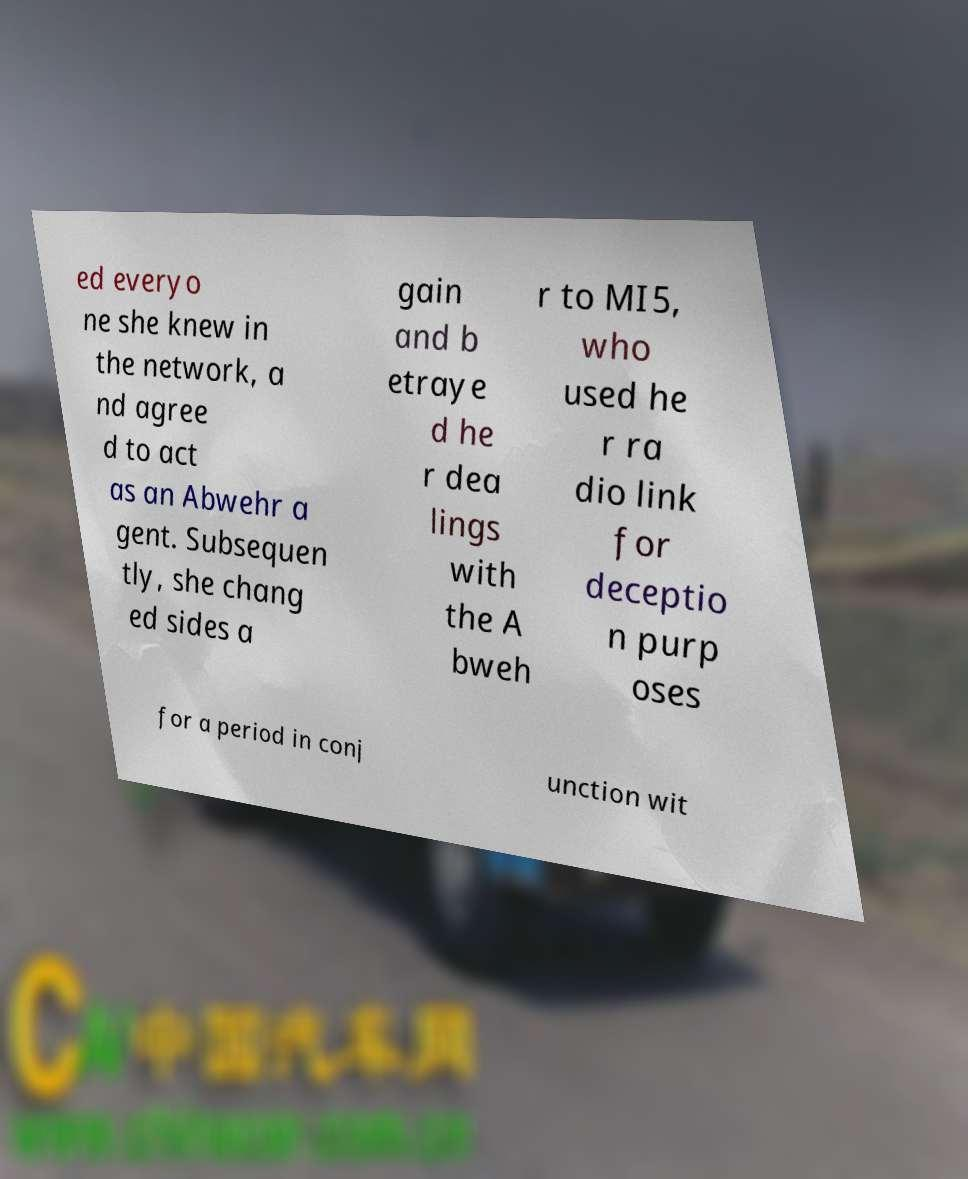Could you extract and type out the text from this image? ed everyo ne she knew in the network, a nd agree d to act as an Abwehr a gent. Subsequen tly, she chang ed sides a gain and b etraye d he r dea lings with the A bweh r to MI5, who used he r ra dio link for deceptio n purp oses for a period in conj unction wit 